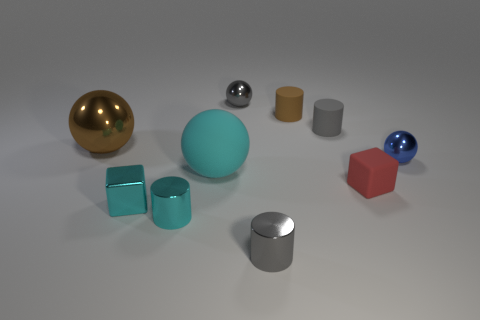Which objects are taller than the cyan cylinder? Evaluating the objects, it appears that both the silver cylinder and the golden sphere stand taller than the cyan cylinder. 